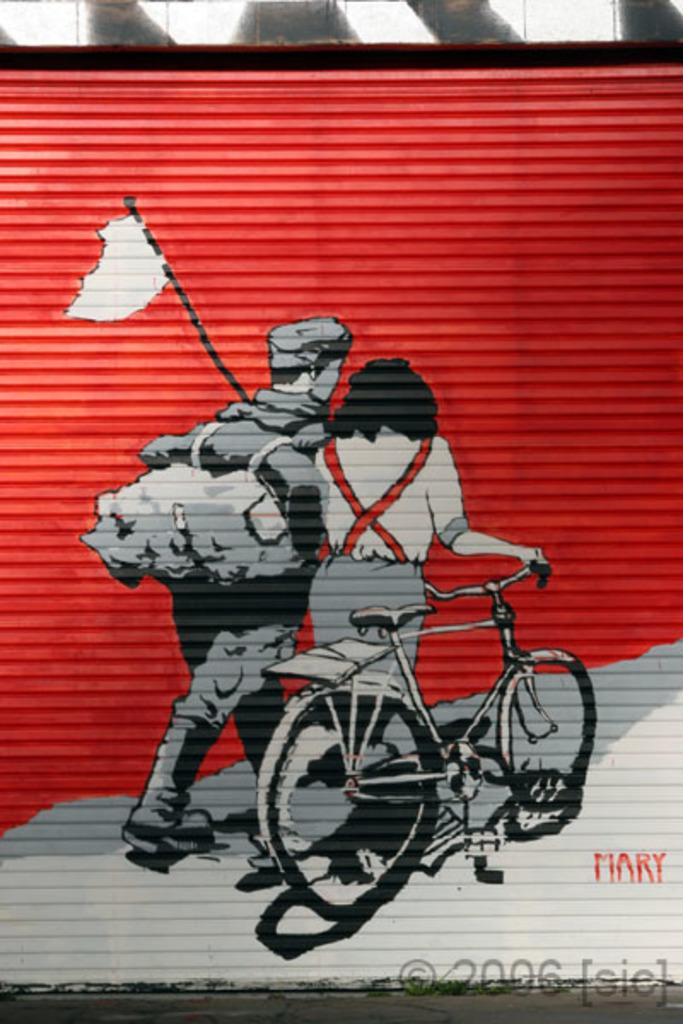What is the main subject in the foreground of the image? There is a painting on a shutter in the foreground of the image. What can be seen at the top of the image? There is a wall visible at the top of the image. What is visible at the bottom of the image? There is a road visible at the bottom of the image. What type of waste can be seen in the painting on the shutter? There is no waste visible in the painting on the shutter; it is a painting and not a real-life scene. 